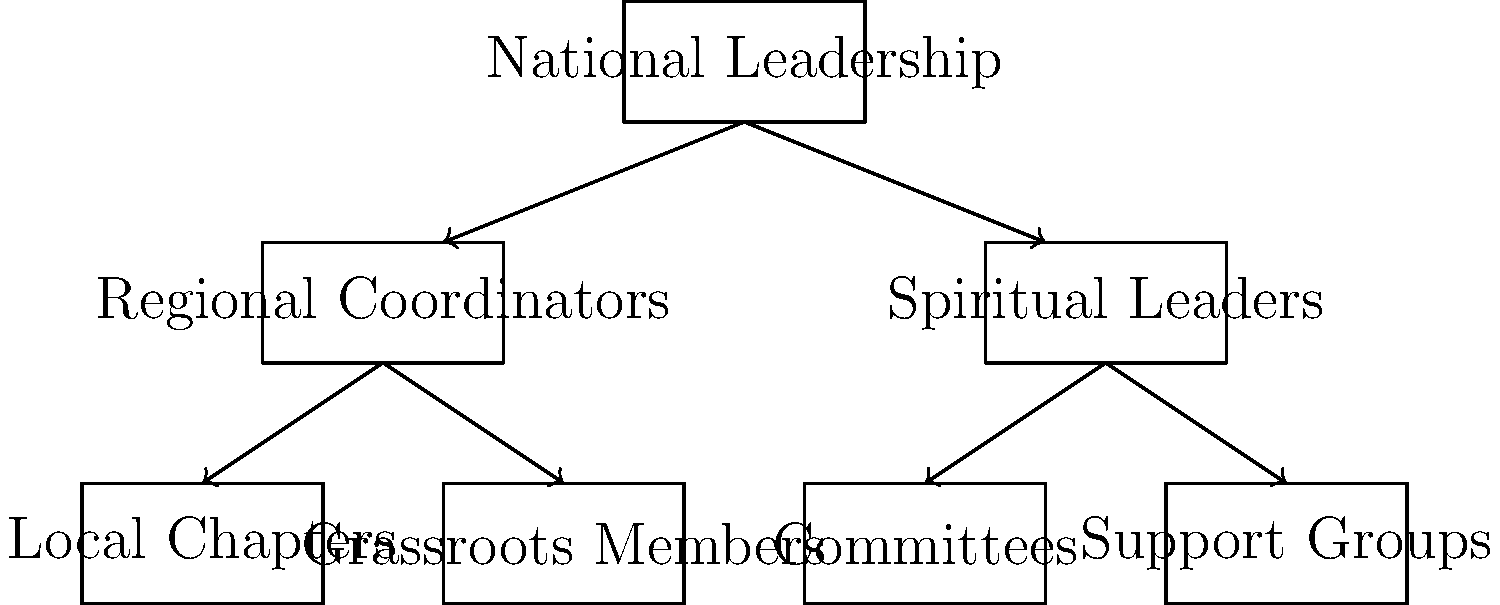Based on the organizational chart of the American Indian Movement (AIM), which component directly connects the National Leadership to the grassroots level of the organization? To answer this question, let's analyze the organizational chart step-by-step:

1. At the top of the chart, we see the "National Leadership" of AIM.

2. Directly below the National Leadership, there are two main branches:
   a) Regional Coordinators
   b) Spiritual Leaders

3. The Regional Coordinators are connected to two lower-level components:
   a) Local Chapters
   b) Grassroots Members

4. The Spiritual Leaders are connected to two other components:
   a) Committees
   b) Support Groups

5. Examining the structure, we can see that the Regional Coordinators serve as the intermediary between the National Leadership and the grassroots level of the organization.

6. The Regional Coordinators have a direct line to both the Local Chapters and the Grassroots Members, which represent the base of the organization.

7. This structure allows for efficient communication and coordination between the top leadership and the grassroots level, ensuring that the movement's goals and strategies are effectively implemented at all levels.

Therefore, the component that directly connects the National Leadership to the grassroots level of the organization is the Regional Coordinators.
Answer: Regional Coordinators 